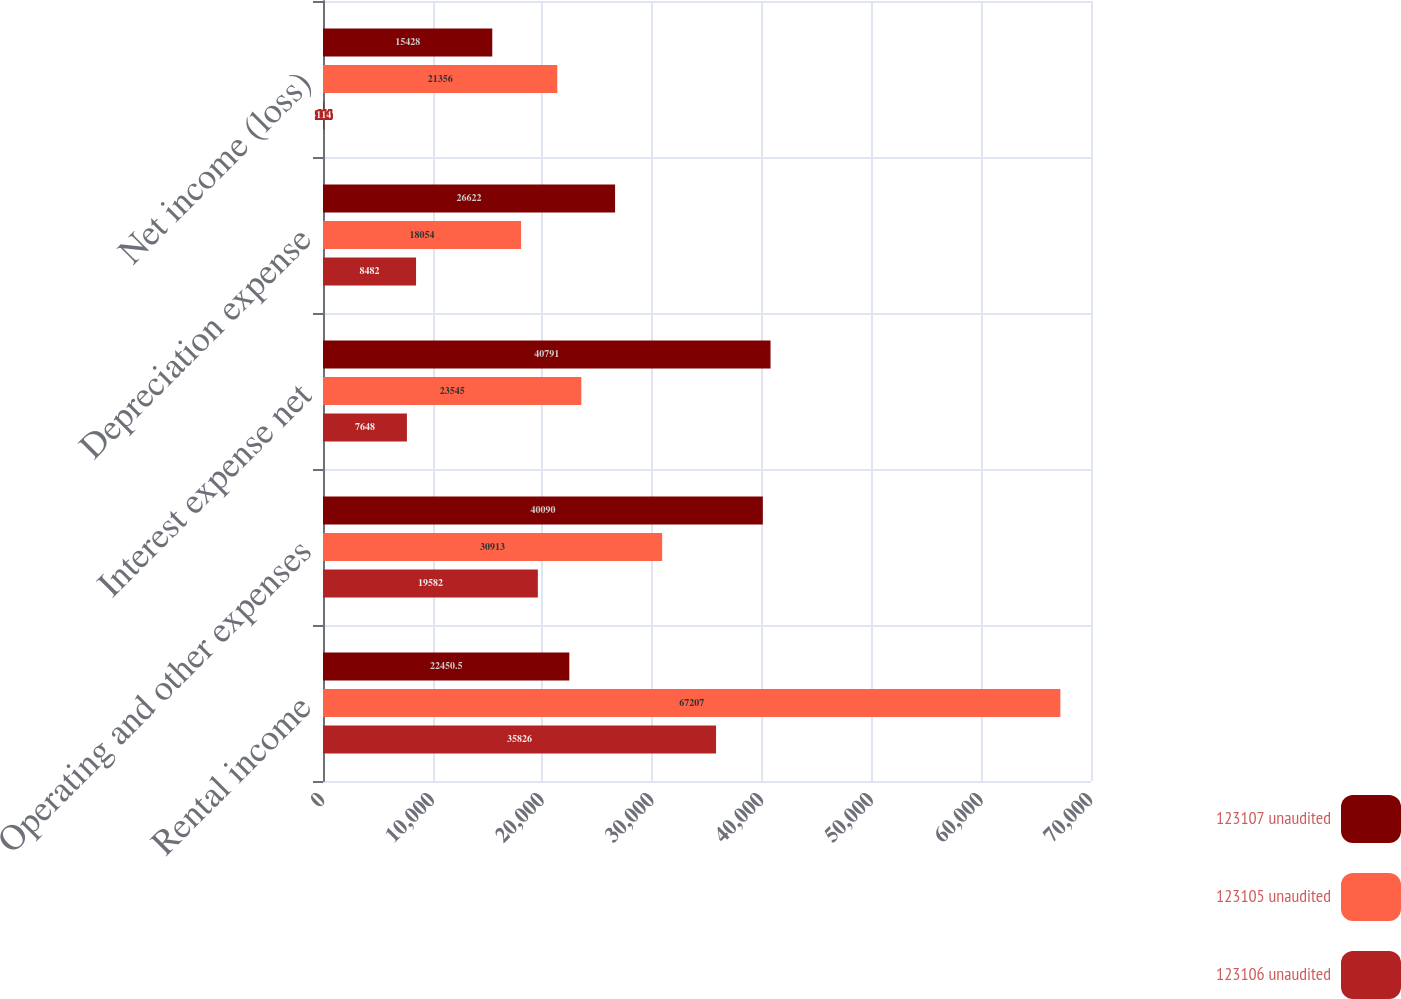Convert chart to OTSL. <chart><loc_0><loc_0><loc_500><loc_500><stacked_bar_chart><ecel><fcel>Rental income<fcel>Operating and other expenses<fcel>Interest expense net<fcel>Depreciation expense<fcel>Net income (loss)<nl><fcel>123107 unaudited<fcel>22450.5<fcel>40090<fcel>40791<fcel>26622<fcel>15428<nl><fcel>123105 unaudited<fcel>67207<fcel>30913<fcel>23545<fcel>18054<fcel>21356<nl><fcel>123106 unaudited<fcel>35826<fcel>19582<fcel>7648<fcel>8482<fcel>114<nl></chart> 